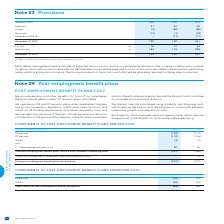According to Bce's financial document, How is interest rate risk managed? using a liability matching approach, which reduces the exposure of the DB plans to a mismatch between investment growth and obligation growth.. The document states: "The interest rate risk is managed using a liability matching approach, which reduces the exposure of the DB plans to a mismatch between investment gro..." Also, How is longevity risk managed? using a longevity swap, which reduces the exposure of the DB plans to an increase in life expectancy.. The document states: "The longevity risk is managed using a longevity swap, which reduces the exposure of the DB plans to an increase in life expectancy...." Also, What are the components for post-employment benefit plans service cost? The document contains multiple relevant values: DB pension, DC pension, OPEBs. From the document: "DB pension (193) (213) DC pension (110) (106) OPEBs (3) (3)..." Also, How many post-employment benefit plans are there? Counting the relevant items in the document: DB pension, DC pension, OPEBs, I find 3 instances. The key data points involved are: DB pension, DC pension, OPEBs. Also, can you calculate: What is the change in capitalized benefit plans cost in 2019? Based on the calculation: 59-56, the result is 3. This is based on the information: "Capitalized benefit plans cost 59 56 Capitalized benefit plans cost 59 56..." The key data points involved are: 56, 59. Also, can you calculate: What is the average total post-employment benefit plans service cost over 2018 and 2019? To answer this question, I need to perform calculations using the financial data. The calculation is: (-247+(-270))/2, which equals -258.5. This is based on the information: "t plans service cost included in operating costs (247) (266) t plans service cost included in operating costs (247) (266) post-employment benefit plans service cost (247) (270)..." The key data points involved are: 247, 270. 